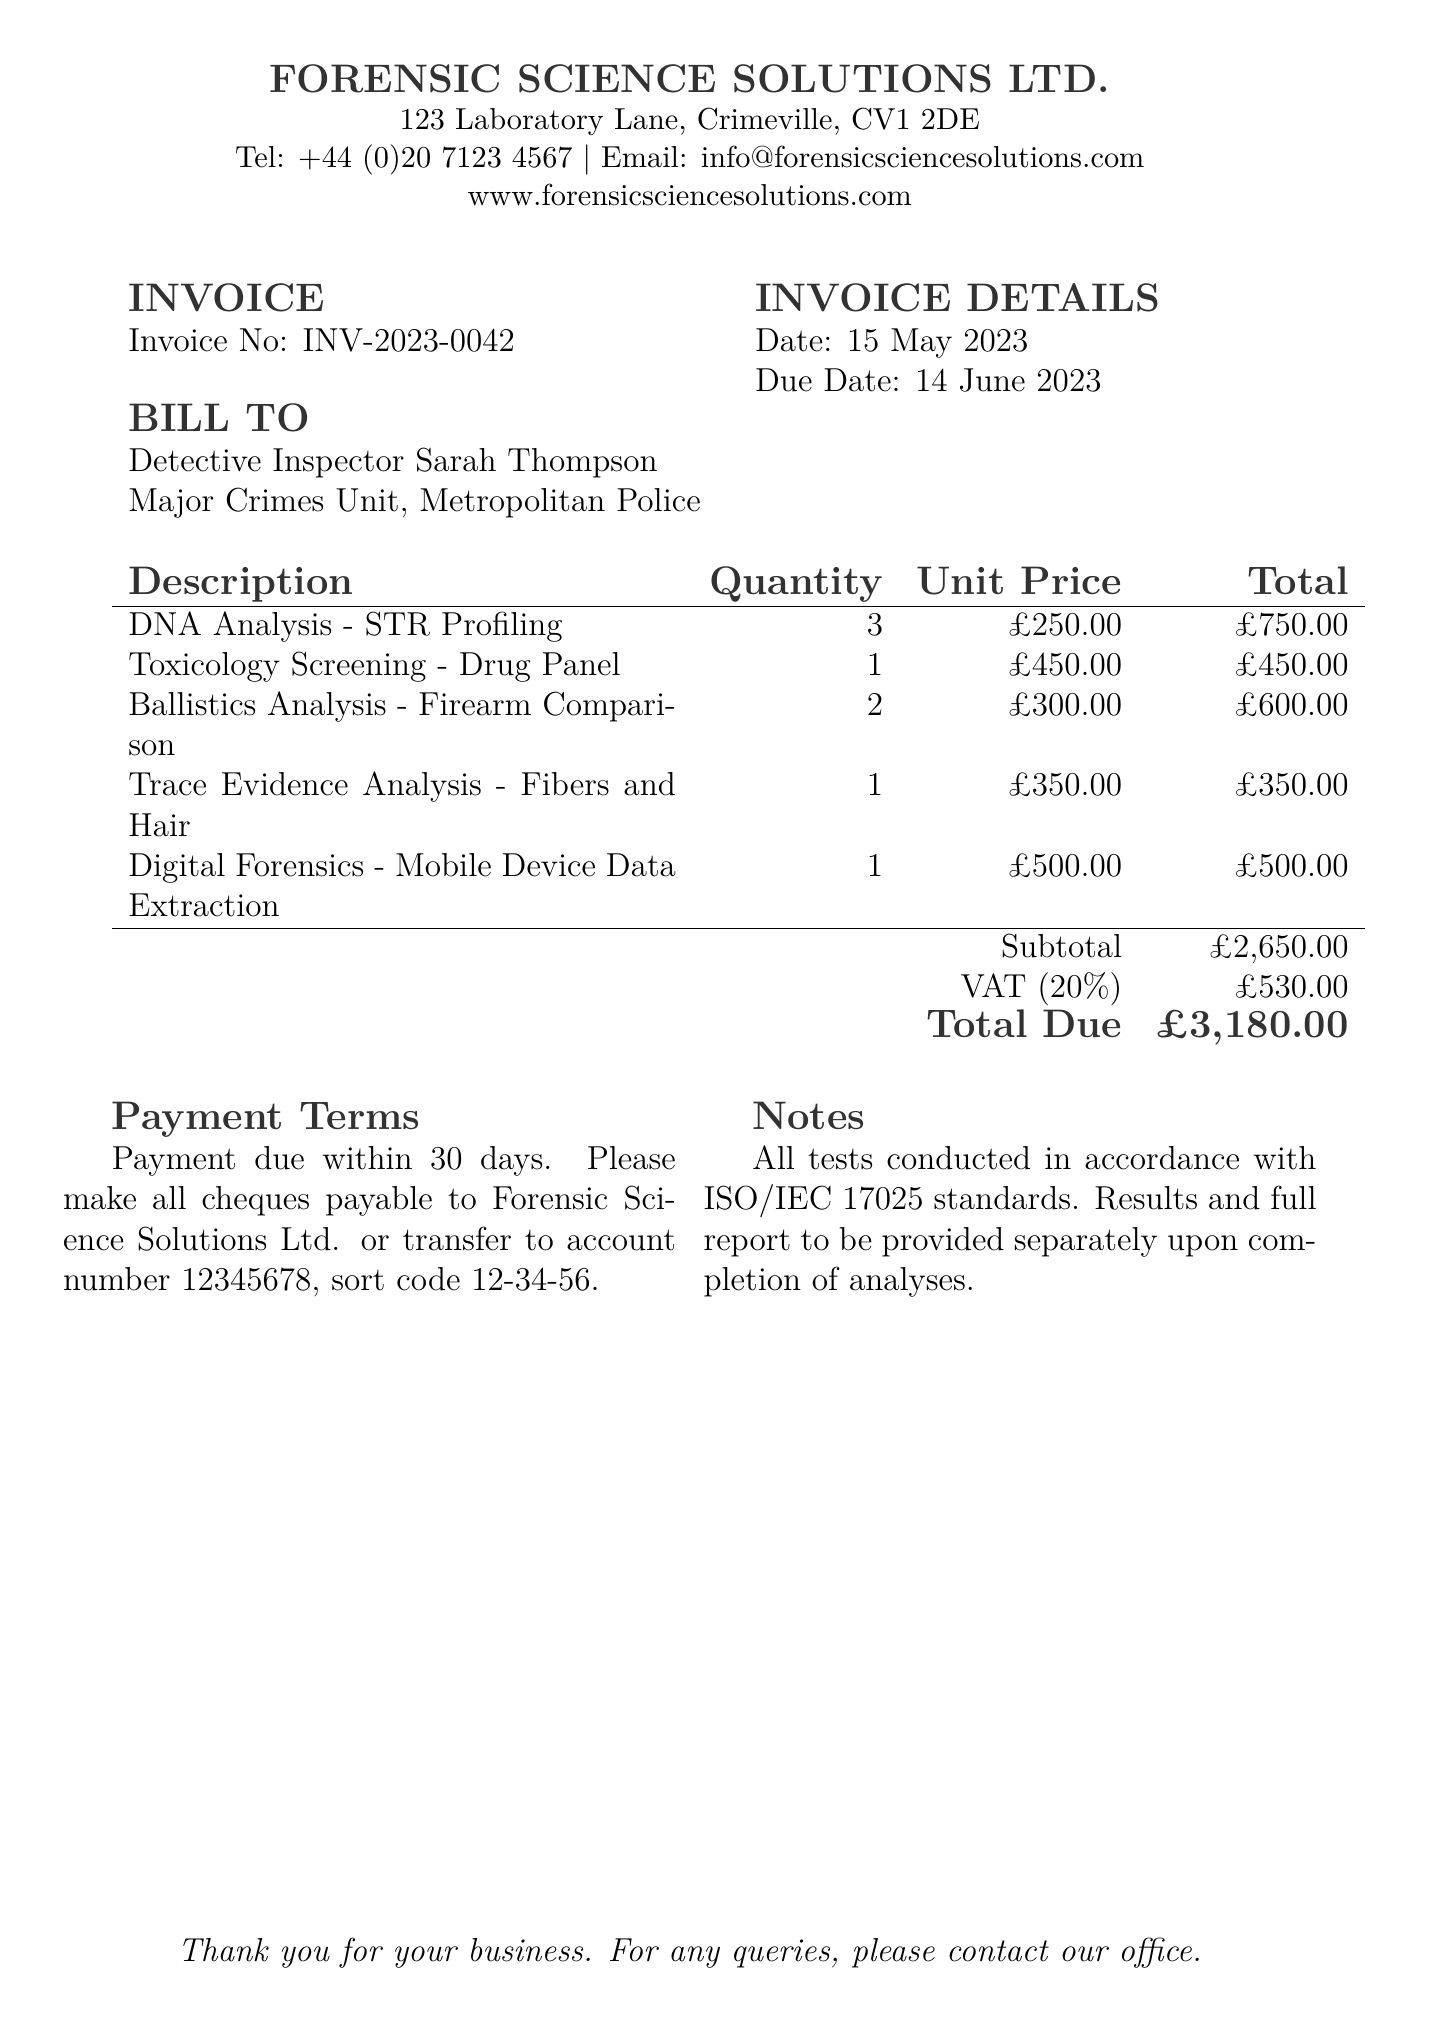What is the invoice number? The invoice number is listed in the invoice details section, specifically labeled as "Invoice No."
Answer: INV-2023-0042 What is the subtotal amount? The subtotal amount is the sum of all individual test costs before tax, located at the end of the itemized services.
Answer: £2,650.00 Who is the invoice addressed to? The invoice is addressed to the detective inspector, given in the "BILL TO" section.
Answer: Detective Inspector Sarah Thompson How many DNA analyses were conducted? The quantity of DNA analyses is specified in the description of services provided.
Answer: 3 What is the VAT percentage listed in the invoice? The VAT percentage is indicated next to the VAT charge in the total section of the invoice.
Answer: 20% What is the total amount due? The total due amount can be found prominently displayed at the end of the invoice, under the "Total Due" section.
Answer: £3,180.00 What are the payment terms? The payment terms specify when payment is due and acceptable payment methods, located in the "Payment Terms" section.
Answer: Payment due within 30 days How many different types of analyses are included in the invoice? The number of different analyses can be determined by counting the descriptions in the provided services section.
Answer: 5 When is the due date for payment? The due date for payment is declared under "INVOICE DETAILS."
Answer: 14 June 2023 